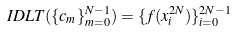Convert formula to latex. <formula><loc_0><loc_0><loc_500><loc_500>I D L T ( \{ c _ { m } \} _ { m = 0 } ^ { N - 1 } ) = \{ f ( x ^ { 2 N } _ { i } ) \} _ { i = 0 } ^ { 2 N - 1 }</formula> 